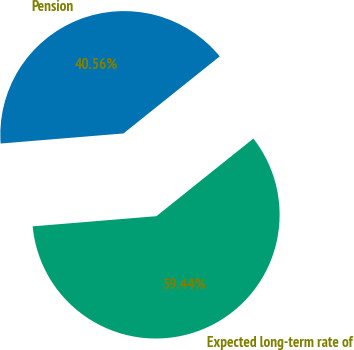Convert chart. <chart><loc_0><loc_0><loc_500><loc_500><pie_chart><fcel>Pension<fcel>Expected long-term rate of<nl><fcel>40.56%<fcel>59.44%<nl></chart> 